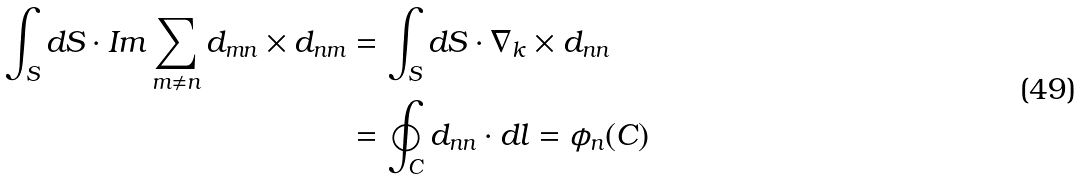<formula> <loc_0><loc_0><loc_500><loc_500>\int _ { S } d { S } \cdot { I m } \sum _ { m \neq n } { d _ { m n } } \times { d _ { n m } } & = \int _ { S } d { S } \cdot \nabla _ { k } \times { d _ { n n } } \\ & = \oint _ { C } { d _ { n n } } \cdot { d l } = \phi _ { n } ( C ) \\</formula> 